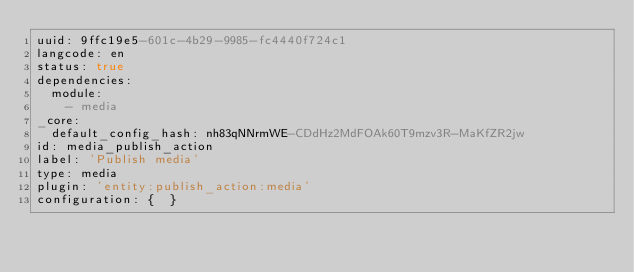<code> <loc_0><loc_0><loc_500><loc_500><_YAML_>uuid: 9ffc19e5-601c-4b29-9985-fc4440f724c1
langcode: en
status: true
dependencies:
  module:
    - media
_core:
  default_config_hash: nh83qNNrmWE-CDdHz2MdFOAk60T9mzv3R-MaKfZR2jw
id: media_publish_action
label: 'Publish media'
type: media
plugin: 'entity:publish_action:media'
configuration: {  }
</code> 